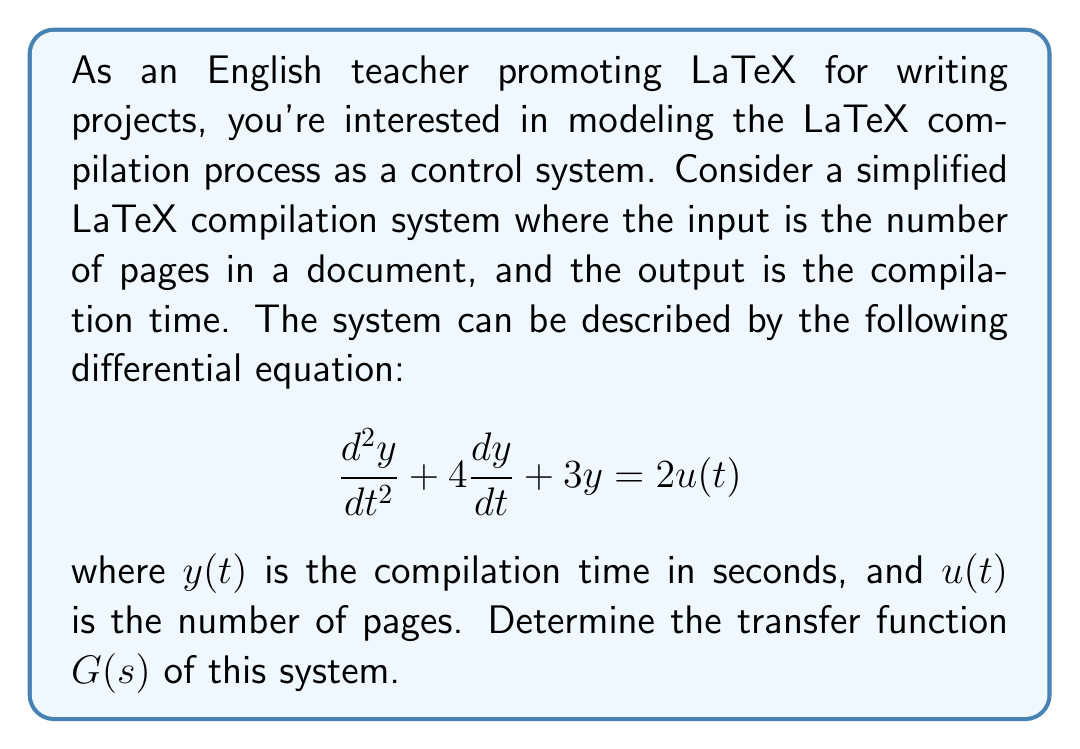Provide a solution to this math problem. To find the transfer function, we need to follow these steps:

1. Take the Laplace transform of both sides of the differential equation, assuming zero initial conditions:

   $$s^2Y(s) + 4sY(s) + 3Y(s) = 2U(s)$$

2. Factor out $Y(s)$ on the left side:

   $$(s^2 + 4s + 3)Y(s) = 2U(s)$$

3. Divide both sides by $(s^2 + 4s + 3)$:

   $$Y(s) = \frac{2}{s^2 + 4s + 3}U(s)$$

4. The transfer function $G(s)$ is defined as the ratio of the output $Y(s)$ to the input $U(s)$:

   $$G(s) = \frac{Y(s)}{U(s)} = \frac{2}{s^2 + 4s + 3}$$

This transfer function represents how the LaTeX compilation system responds to changes in the number of pages in the document. It can be used to analyze the system's behavior and predict compilation times for different document sizes.
Answer: $$G(s) = \frac{2}{s^2 + 4s + 3}$$ 